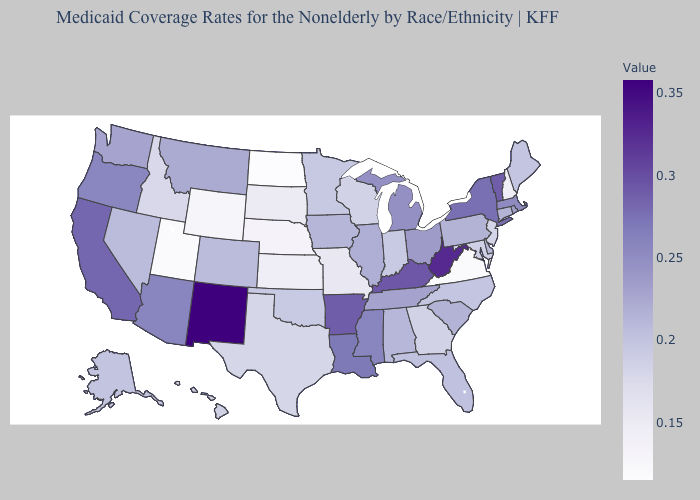Does New Mexico have the highest value in the USA?
Short answer required. Yes. Does North Dakota have the lowest value in the USA?
Be succinct. Yes. Among the states that border Kansas , does Colorado have the highest value?
Keep it brief. Yes. Does New Mexico have the highest value in the USA?
Write a very short answer. Yes. Among the states that border Missouri , does Oklahoma have the lowest value?
Short answer required. No. Which states hav the highest value in the South?
Write a very short answer. West Virginia. Does South Carolina have the lowest value in the USA?
Keep it brief. No. Does Michigan have the highest value in the MidWest?
Short answer required. Yes. 